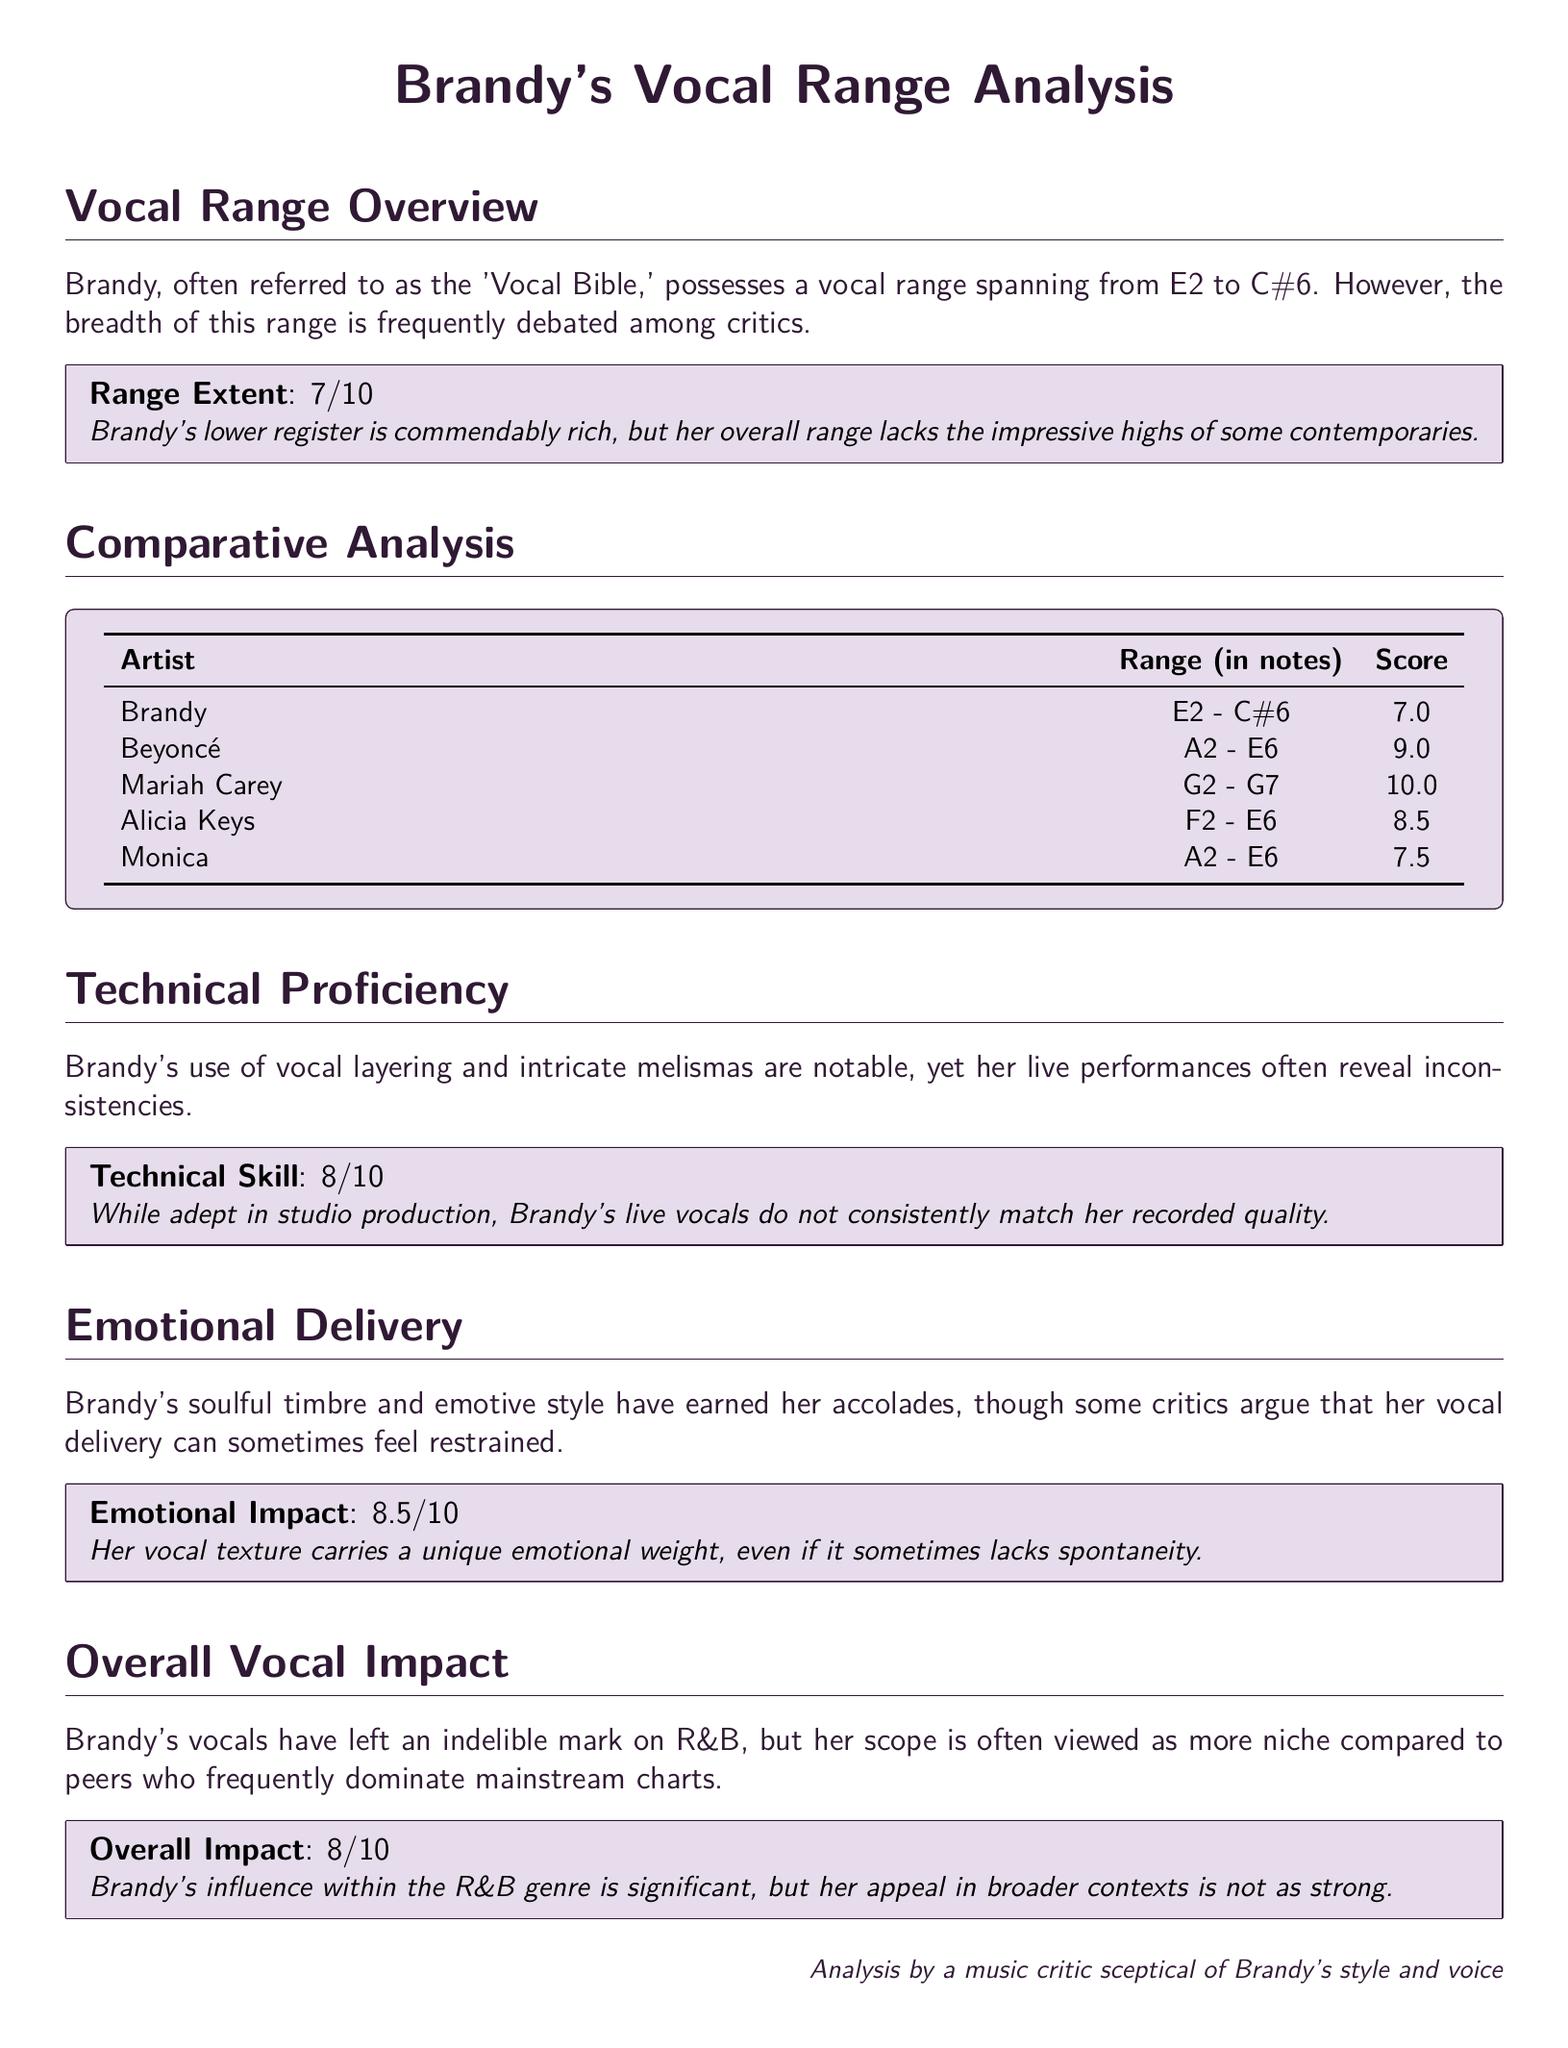What is Brandy's vocal range? The document states that Brandy's vocal range spans from E2 to C#6.
Answer: E2 - C#6 What score did Brandy receive for her range extent? The score for Brandy's range extent, as noted in the scorebox, is 7.
Answer: 7 Which artist has the widest vocal range according to the document? The table shows that Mariah Carey has the widest vocal range, spanning G2 to G7.
Answer: Mariah Carey What is the score for Brandy's technical skill? The score for Brandy's technical skill is provided in the scorebox as 8.
Answer: 8 What is Brandy's emotional impact score? The score for emotional impact given to Brandy is mentioned in the respective scorebox as 8.5.
Answer: 8.5 How does Brandy's overall impact score compare to Alicia Keys'? Both scores are provided: Brandy is 8, and Alicia Keys is 8.5, indicating a slight difference.
Answer: Brandy is 8, Alicia Keys is 8.5 What aspect of Brandy's live performances is noted as inconsistent? The analysis highlights inconsistencies in Brandy's live performances compared to her studio recordings.
Answer: Live performances What is the emotional weight of Brandy's vocal texture described as? The document asserts that Brandy's vocal texture carries unique emotional weight.
Answer: Unique emotional weight What overall score did Brandy receive? The overall score for Brandy's vocal impact is presented in the scorebox as 8.
Answer: 8 